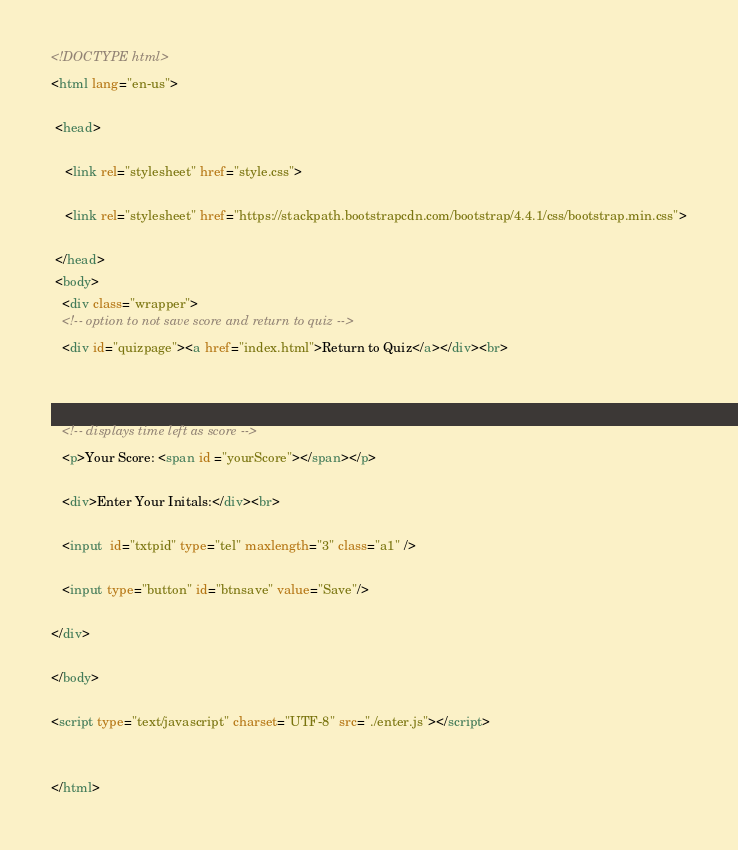Convert code to text. <code><loc_0><loc_0><loc_500><loc_500><_HTML_><!DOCTYPE html>
<html lang="en-us">

 <head>

    <link rel="stylesheet" href="style.css">

    <link rel="stylesheet" href="https://stackpath.bootstrapcdn.com/bootstrap/4.4.1/css/bootstrap.min.css">

 </head>
 <body>
   <div class="wrapper">
   <!-- option to not save score and return to quiz -->
   <div id="quizpage"><a href="index.html">Return to Quiz</a></div><br>

   

   <!-- displays time left as score -->
   <p>Your Score: <span id ="yourScore"></span></p>
               
   <div>Enter Your Initals:</div><br>

   <input  id="txtpid" type="tel" maxlength="3" class="a1" />  
     
   <input type="button" id="btnsave" value="Save"/>

</div>

</body>

<script type="text/javascript" charset="UTF-8" src="./enter.js"></script>


</html></code> 